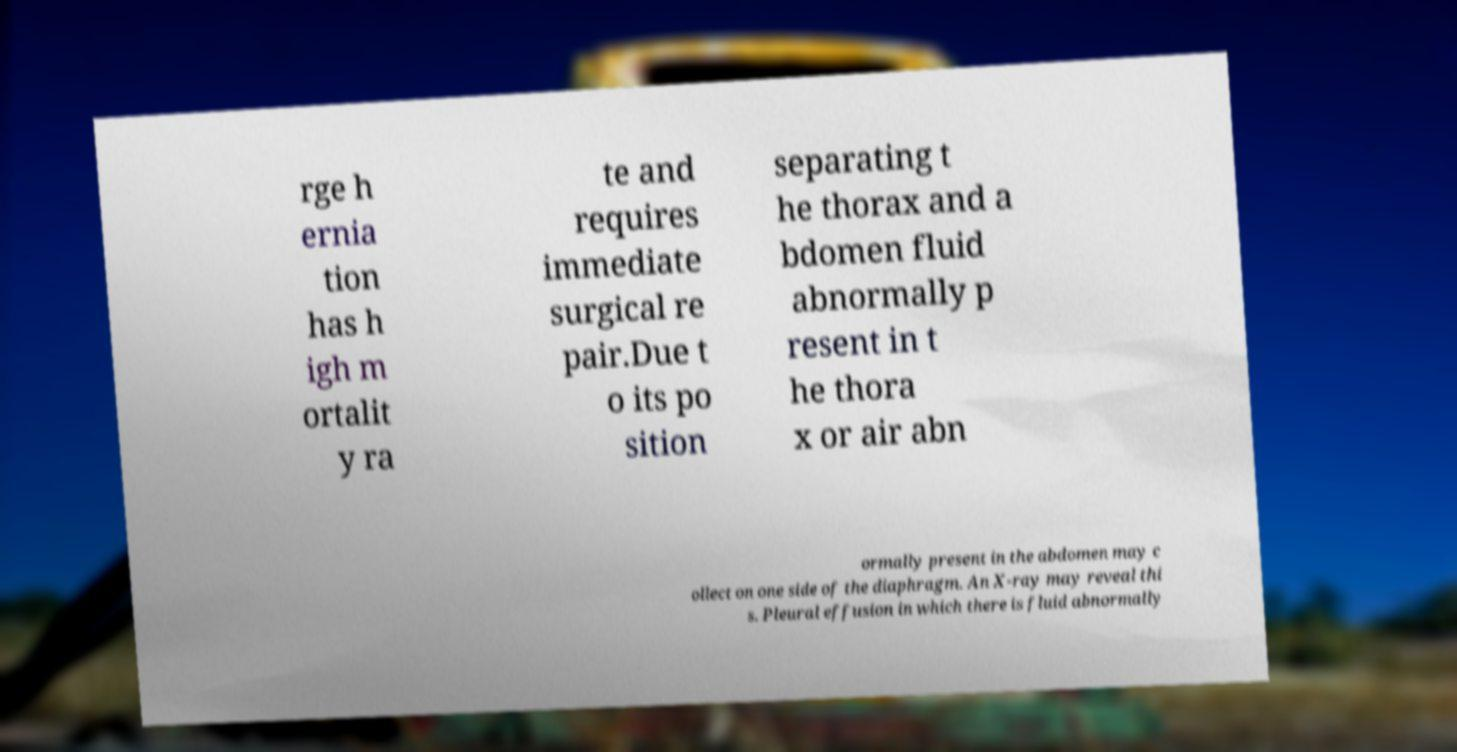Please read and relay the text visible in this image. What does it say? rge h ernia tion has h igh m ortalit y ra te and requires immediate surgical re pair.Due t o its po sition separating t he thorax and a bdomen fluid abnormally p resent in t he thora x or air abn ormally present in the abdomen may c ollect on one side of the diaphragm. An X-ray may reveal thi s. Pleural effusion in which there is fluid abnormally 